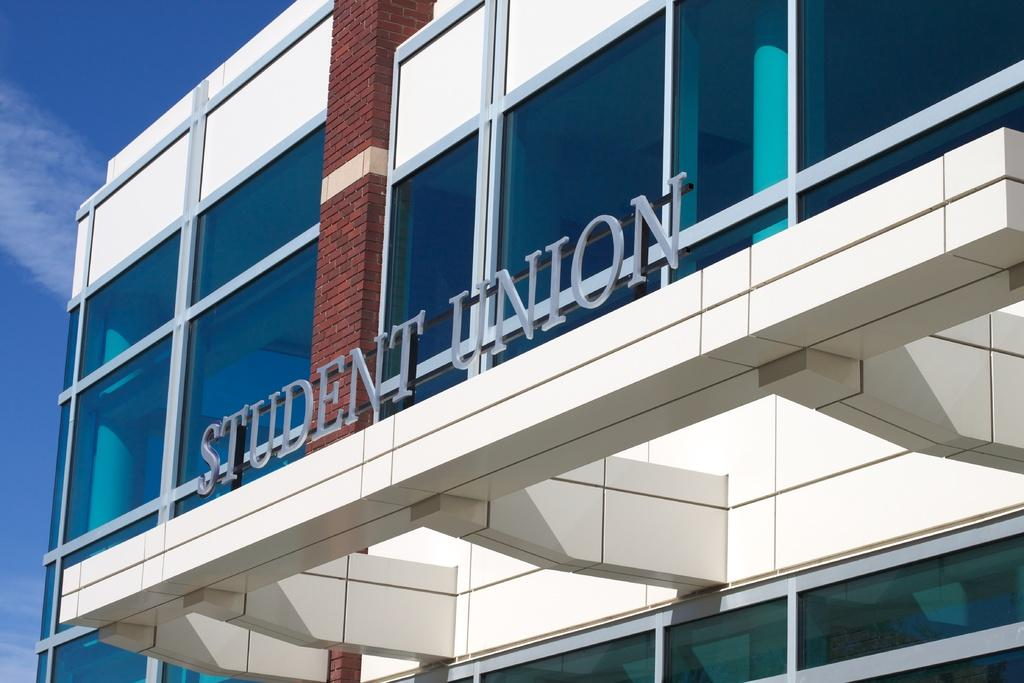What type of structure is visible in the image? There is a building in the image. What is attached to the metal rod in the image? There are letters on the metal rod in the image. What can be seen in the sky in the background of the image? There are clouds in the sky in the background of the image. What type of plate is being used to catch the water from the elbow in the image? There is no plate or elbow present in the image. 